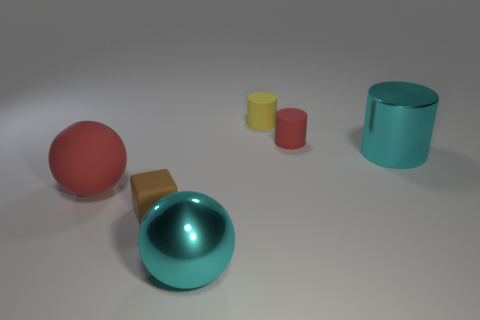What is the shape of the big shiny thing that is the same color as the big cylinder?
Provide a short and direct response. Sphere. Are there more small brown rubber things to the right of the tiny yellow cylinder than tiny cylinders?
Provide a succinct answer. No. Are there any large objects behind the tiny red cylinder?
Provide a succinct answer. No. Do the brown block and the cyan cylinder have the same size?
Keep it short and to the point. No. What size is the cyan thing that is the same shape as the large red rubber object?
Your answer should be compact. Large. The block in front of the red matte thing on the left side of the small red cylinder is made of what material?
Your response must be concise. Rubber. Do the yellow matte object and the small brown object have the same shape?
Your response must be concise. No. How many matte things are in front of the large cylinder and behind the small brown object?
Provide a short and direct response. 1. Are there an equal number of metallic cylinders that are to the left of the brown rubber block and cyan balls on the left side of the cyan cylinder?
Offer a terse response. No. There is a thing on the left side of the tiny cube; does it have the same size as the rubber cylinder that is on the left side of the small red object?
Your answer should be very brief. No. 